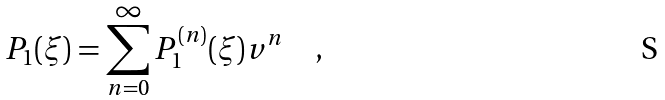<formula> <loc_0><loc_0><loc_500><loc_500>P _ { 1 } ( \xi ) = \sum _ { n = 0 } ^ { \infty } P _ { 1 } ^ { ( n ) } ( \xi ) v ^ { n } \quad ,</formula> 